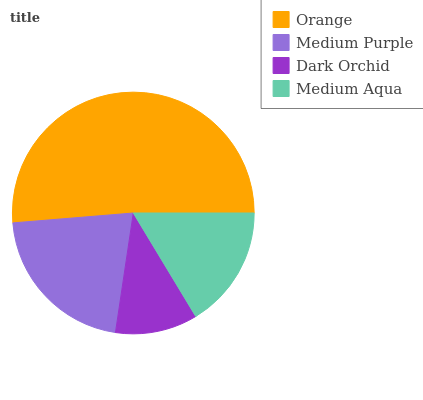Is Dark Orchid the minimum?
Answer yes or no. Yes. Is Orange the maximum?
Answer yes or no. Yes. Is Medium Purple the minimum?
Answer yes or no. No. Is Medium Purple the maximum?
Answer yes or no. No. Is Orange greater than Medium Purple?
Answer yes or no. Yes. Is Medium Purple less than Orange?
Answer yes or no. Yes. Is Medium Purple greater than Orange?
Answer yes or no. No. Is Orange less than Medium Purple?
Answer yes or no. No. Is Medium Purple the high median?
Answer yes or no. Yes. Is Medium Aqua the low median?
Answer yes or no. Yes. Is Dark Orchid the high median?
Answer yes or no. No. Is Orange the low median?
Answer yes or no. No. 